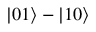Convert formula to latex. <formula><loc_0><loc_0><loc_500><loc_500>| 0 1 \rangle - | 1 0 \rangle</formula> 